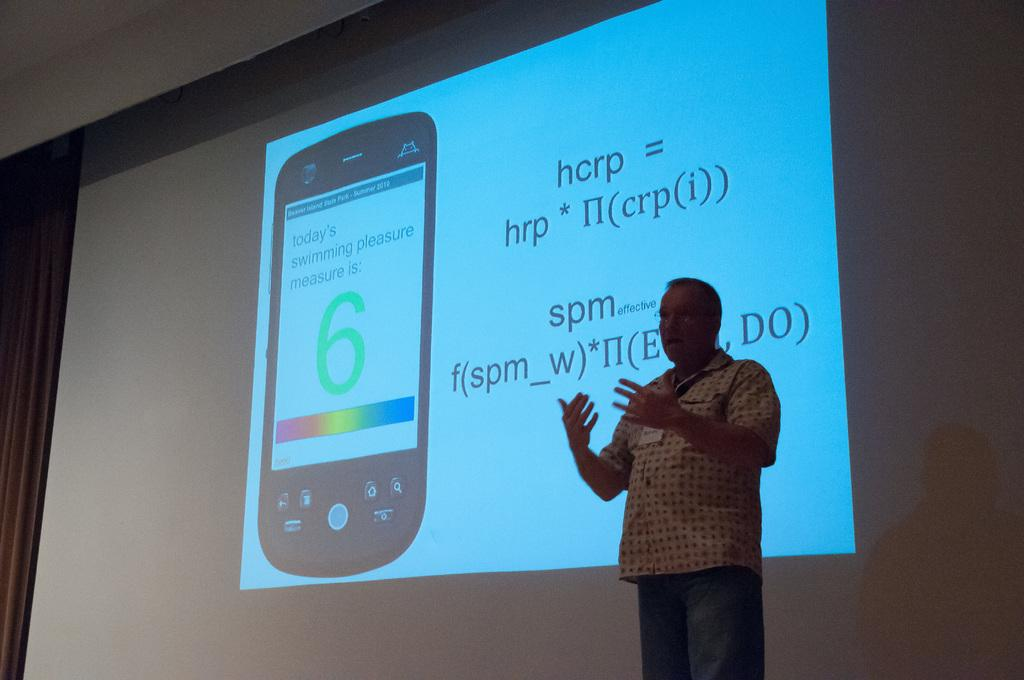<image>
Render a clear and concise summary of the photo. man giving lecture in front of projection showing formula and a cellphone with its screen showing "today's swimming pleasure measure is: 6" 